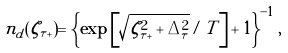<formula> <loc_0><loc_0><loc_500><loc_500>n _ { d } ( \zeta _ { \tau + } ) = \left \{ \exp \left [ \sqrt { \zeta _ { \tau + } ^ { 2 } + \Delta _ { \tau } ^ { 2 } } / T \right ] + 1 \right \} ^ { - 1 } ,</formula> 